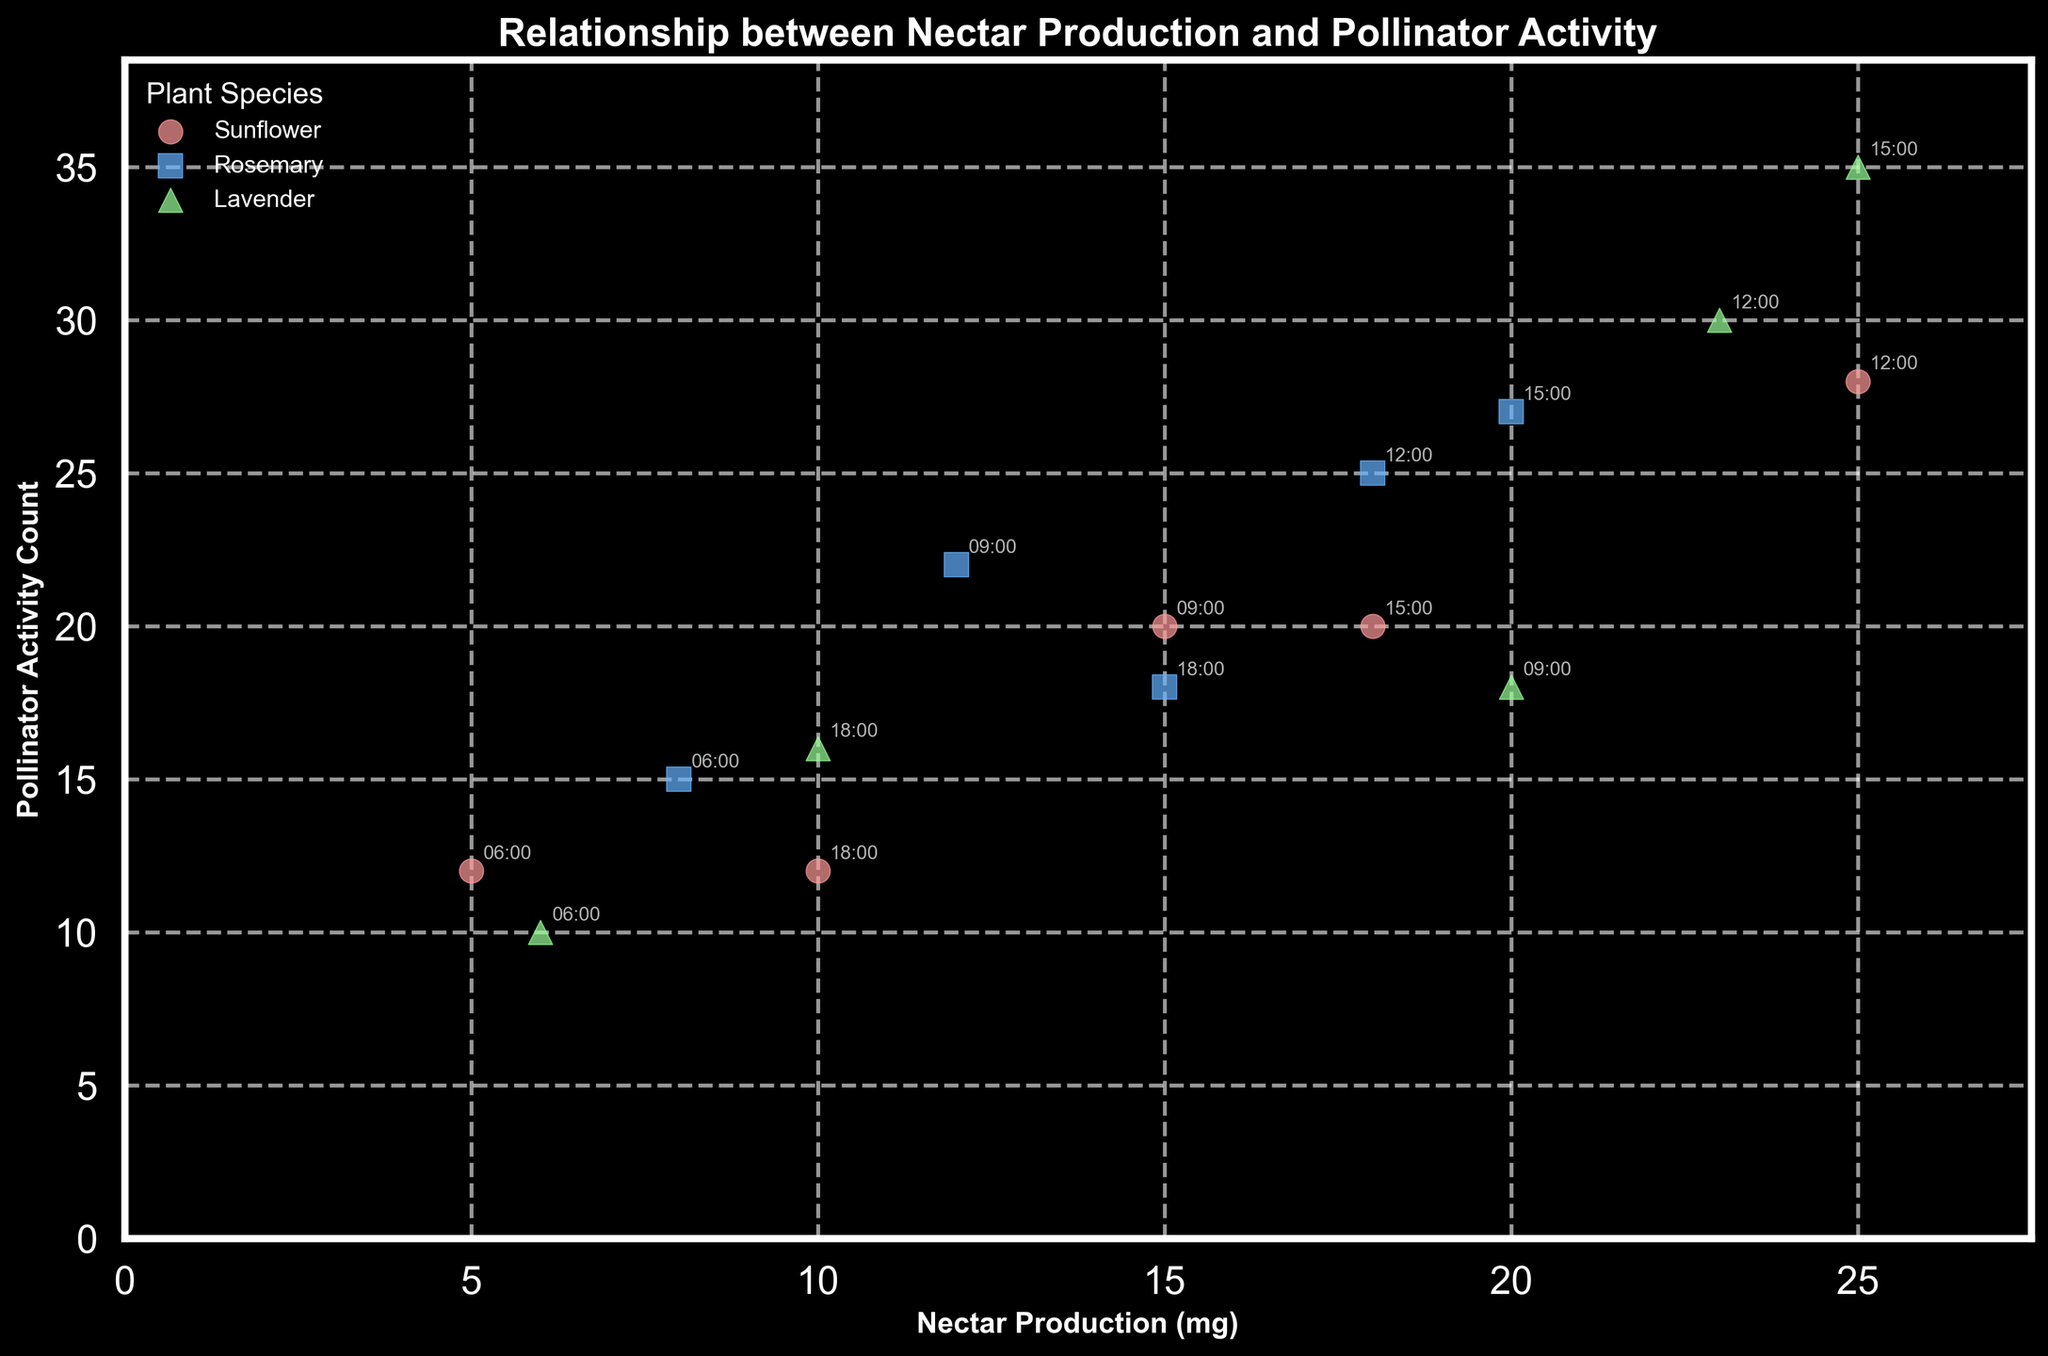What is the title of the figure? The title of the figure is usually located at the top of the plot, and it provides a general overview of what the plot represents. The title of this figure is "Relationship between Nectar Production and Pollinator Activity," as indicated in the provided code.
Answer: Relationship between Nectar Production and Pollinator Activity Which plant species have the highest nectar production? The scatter plot represents different plant species, and the nectar production can be visually interpreted by looking at the scatter points. From the plot, it is noticeable that Lavender has the highest nectar production at several time points.
Answer: Lavender At what time does Sunflower have the highest pollinator activity count? To determine this, we look at the annotations on the scatter points with the highest pollinator activity count for Sunflower. By observing the figure, we can see that at 12:00, Sunflower reaches its highest pollinator activity count.
Answer: 12:00 What is the average nectar production of Rosemary across the times of day? To find the average, sum all the nectar production values for Rosemary and divide by the number of data points. The values are 8, 12, 18, 20, and 15. Therefore, the average is (8 + 12 + 18 + 20 + 15) / 5 = 14.6.
Answer: 14.6 Which insect species shows the highest pollinator activity with Lavender at 15:00? By examining the figure and the annotations for the time 15:00, we can see that Lavender has the highest pollinator activity count at this time, and the corresponding insect species annotation indicates that it is the Butterfly.
Answer: Butterfly Comparing Sunflower and Lavender, which plant has the most consistent pollinator activity throughout the day? To determine consistency, one would look at the spread of the pollinator activity counts for each plant species throughout the day. Lavender appears to have a more consistent pollinator activity count, as its values are relatively high and less variable compared to Sunflower, which shows significant variation.
Answer: Lavender What is the total pollinator activity count for Honeybee across all times of day? We add up all the pollinator activity counts for Honeybee from the figure. The values are 12, 15, 18, 28, 20, and 18. Therefore, the total is 12 + 15 + 18 + 28 + 20 + 18 = 111.
Answer: 111 Is there a general trend in the relationship between nectar production and pollinator activity? By observing the scatter plot, one can see if there's a visible trend in how the nectar production relates to pollinator activity. There seems to be a positive correlation; as nectar production increases, pollinator activity generally also increases.
Answer: Positive correlation 